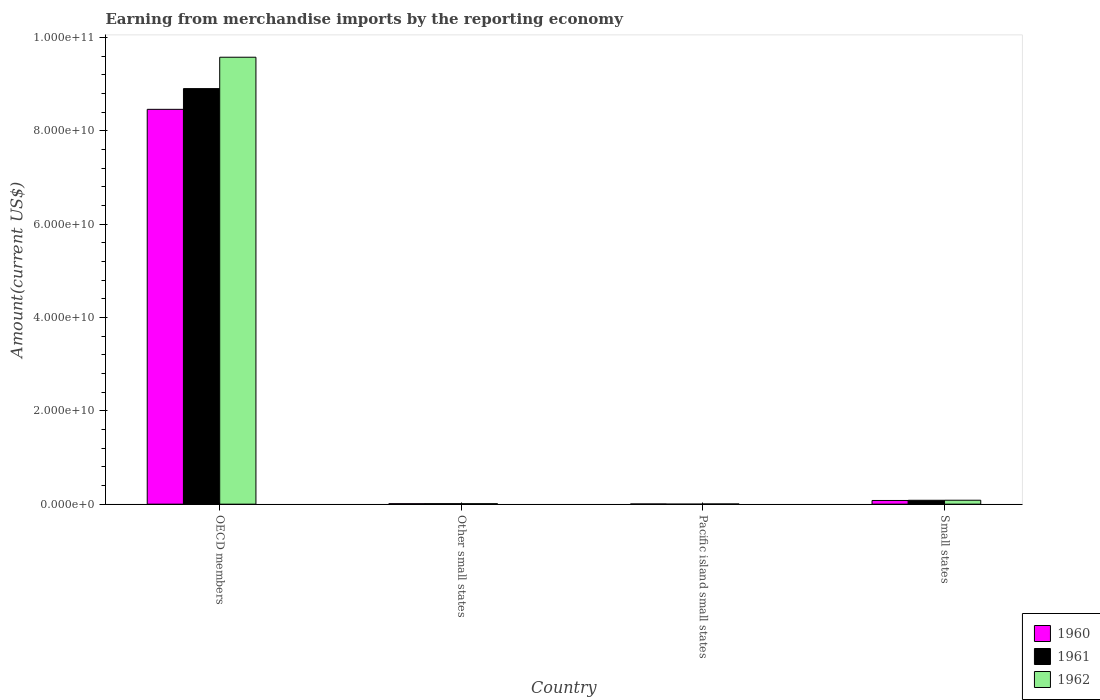How many bars are there on the 2nd tick from the left?
Your response must be concise. 3. How many bars are there on the 1st tick from the right?
Ensure brevity in your answer.  3. In how many cases, is the number of bars for a given country not equal to the number of legend labels?
Your answer should be compact. 0. What is the amount earned from merchandise imports in 1962 in OECD members?
Provide a succinct answer. 9.57e+1. Across all countries, what is the maximum amount earned from merchandise imports in 1962?
Provide a succinct answer. 9.57e+1. Across all countries, what is the minimum amount earned from merchandise imports in 1962?
Provide a succinct answer. 4.33e+07. In which country was the amount earned from merchandise imports in 1960 maximum?
Ensure brevity in your answer.  OECD members. In which country was the amount earned from merchandise imports in 1961 minimum?
Provide a short and direct response. Pacific island small states. What is the total amount earned from merchandise imports in 1960 in the graph?
Your answer should be very brief. 8.55e+1. What is the difference between the amount earned from merchandise imports in 1961 in OECD members and that in Other small states?
Make the answer very short. 8.89e+1. What is the difference between the amount earned from merchandise imports in 1962 in Other small states and the amount earned from merchandise imports in 1960 in OECD members?
Make the answer very short. -8.45e+1. What is the average amount earned from merchandise imports in 1960 per country?
Offer a very short reply. 2.14e+1. What is the difference between the amount earned from merchandise imports of/in 1961 and amount earned from merchandise imports of/in 1962 in Pacific island small states?
Give a very brief answer. -4.21e+07. In how many countries, is the amount earned from merchandise imports in 1960 greater than 52000000000 US$?
Provide a short and direct response. 1. What is the ratio of the amount earned from merchandise imports in 1960 in OECD members to that in Small states?
Ensure brevity in your answer.  107.01. Is the difference between the amount earned from merchandise imports in 1961 in OECD members and Other small states greater than the difference between the amount earned from merchandise imports in 1962 in OECD members and Other small states?
Your answer should be compact. No. What is the difference between the highest and the second highest amount earned from merchandise imports in 1960?
Ensure brevity in your answer.  8.38e+1. What is the difference between the highest and the lowest amount earned from merchandise imports in 1962?
Ensure brevity in your answer.  9.57e+1. Is the sum of the amount earned from merchandise imports in 1960 in Other small states and Pacific island small states greater than the maximum amount earned from merchandise imports in 1961 across all countries?
Your response must be concise. No. What does the 1st bar from the left in Small states represents?
Offer a very short reply. 1960. Are all the bars in the graph horizontal?
Your response must be concise. No. How many countries are there in the graph?
Keep it short and to the point. 4. Are the values on the major ticks of Y-axis written in scientific E-notation?
Your answer should be very brief. Yes. Does the graph contain any zero values?
Give a very brief answer. No. How many legend labels are there?
Keep it short and to the point. 3. How are the legend labels stacked?
Offer a terse response. Vertical. What is the title of the graph?
Offer a terse response. Earning from merchandise imports by the reporting economy. What is the label or title of the X-axis?
Offer a terse response. Country. What is the label or title of the Y-axis?
Offer a very short reply. Amount(current US$). What is the Amount(current US$) of 1960 in OECD members?
Ensure brevity in your answer.  8.46e+1. What is the Amount(current US$) in 1961 in OECD members?
Give a very brief answer. 8.90e+1. What is the Amount(current US$) of 1962 in OECD members?
Keep it short and to the point. 9.57e+1. What is the Amount(current US$) in 1960 in Other small states?
Make the answer very short. 1.00e+08. What is the Amount(current US$) in 1961 in Other small states?
Offer a very short reply. 1.02e+08. What is the Amount(current US$) in 1962 in Other small states?
Your answer should be compact. 1.04e+08. What is the Amount(current US$) in 1960 in Pacific island small states?
Keep it short and to the point. 4.12e+07. What is the Amount(current US$) of 1961 in Pacific island small states?
Make the answer very short. 1.20e+06. What is the Amount(current US$) in 1962 in Pacific island small states?
Offer a terse response. 4.33e+07. What is the Amount(current US$) of 1960 in Small states?
Give a very brief answer. 7.90e+08. What is the Amount(current US$) in 1961 in Small states?
Offer a terse response. 8.34e+08. What is the Amount(current US$) in 1962 in Small states?
Provide a succinct answer. 8.44e+08. Across all countries, what is the maximum Amount(current US$) of 1960?
Your answer should be compact. 8.46e+1. Across all countries, what is the maximum Amount(current US$) in 1961?
Ensure brevity in your answer.  8.90e+1. Across all countries, what is the maximum Amount(current US$) of 1962?
Give a very brief answer. 9.57e+1. Across all countries, what is the minimum Amount(current US$) in 1960?
Make the answer very short. 4.12e+07. Across all countries, what is the minimum Amount(current US$) in 1961?
Provide a succinct answer. 1.20e+06. Across all countries, what is the minimum Amount(current US$) of 1962?
Your answer should be compact. 4.33e+07. What is the total Amount(current US$) of 1960 in the graph?
Your answer should be very brief. 8.55e+1. What is the total Amount(current US$) in 1961 in the graph?
Offer a terse response. 9.00e+1. What is the total Amount(current US$) in 1962 in the graph?
Make the answer very short. 9.67e+1. What is the difference between the Amount(current US$) in 1960 in OECD members and that in Other small states?
Give a very brief answer. 8.45e+1. What is the difference between the Amount(current US$) in 1961 in OECD members and that in Other small states?
Give a very brief answer. 8.89e+1. What is the difference between the Amount(current US$) in 1962 in OECD members and that in Other small states?
Your answer should be very brief. 9.56e+1. What is the difference between the Amount(current US$) of 1960 in OECD members and that in Pacific island small states?
Make the answer very short. 8.45e+1. What is the difference between the Amount(current US$) of 1961 in OECD members and that in Pacific island small states?
Provide a succinct answer. 8.90e+1. What is the difference between the Amount(current US$) in 1962 in OECD members and that in Pacific island small states?
Offer a very short reply. 9.57e+1. What is the difference between the Amount(current US$) of 1960 in OECD members and that in Small states?
Provide a succinct answer. 8.38e+1. What is the difference between the Amount(current US$) in 1961 in OECD members and that in Small states?
Offer a very short reply. 8.82e+1. What is the difference between the Amount(current US$) in 1962 in OECD members and that in Small states?
Keep it short and to the point. 9.49e+1. What is the difference between the Amount(current US$) of 1960 in Other small states and that in Pacific island small states?
Your answer should be very brief. 5.90e+07. What is the difference between the Amount(current US$) in 1961 in Other small states and that in Pacific island small states?
Make the answer very short. 1.00e+08. What is the difference between the Amount(current US$) in 1962 in Other small states and that in Pacific island small states?
Your response must be concise. 6.08e+07. What is the difference between the Amount(current US$) of 1960 in Other small states and that in Small states?
Your answer should be compact. -6.90e+08. What is the difference between the Amount(current US$) of 1961 in Other small states and that in Small states?
Give a very brief answer. -7.32e+08. What is the difference between the Amount(current US$) in 1962 in Other small states and that in Small states?
Provide a short and direct response. -7.40e+08. What is the difference between the Amount(current US$) in 1960 in Pacific island small states and that in Small states?
Give a very brief answer. -7.49e+08. What is the difference between the Amount(current US$) in 1961 in Pacific island small states and that in Small states?
Offer a terse response. -8.32e+08. What is the difference between the Amount(current US$) in 1962 in Pacific island small states and that in Small states?
Offer a very short reply. -8.00e+08. What is the difference between the Amount(current US$) of 1960 in OECD members and the Amount(current US$) of 1961 in Other small states?
Your answer should be very brief. 8.45e+1. What is the difference between the Amount(current US$) of 1960 in OECD members and the Amount(current US$) of 1962 in Other small states?
Provide a succinct answer. 8.45e+1. What is the difference between the Amount(current US$) of 1961 in OECD members and the Amount(current US$) of 1962 in Other small states?
Offer a terse response. 8.89e+1. What is the difference between the Amount(current US$) of 1960 in OECD members and the Amount(current US$) of 1961 in Pacific island small states?
Provide a short and direct response. 8.46e+1. What is the difference between the Amount(current US$) in 1960 in OECD members and the Amount(current US$) in 1962 in Pacific island small states?
Provide a succinct answer. 8.45e+1. What is the difference between the Amount(current US$) in 1961 in OECD members and the Amount(current US$) in 1962 in Pacific island small states?
Your answer should be very brief. 8.90e+1. What is the difference between the Amount(current US$) in 1960 in OECD members and the Amount(current US$) in 1961 in Small states?
Give a very brief answer. 8.37e+1. What is the difference between the Amount(current US$) in 1960 in OECD members and the Amount(current US$) in 1962 in Small states?
Provide a short and direct response. 8.37e+1. What is the difference between the Amount(current US$) in 1961 in OECD members and the Amount(current US$) in 1962 in Small states?
Ensure brevity in your answer.  8.82e+1. What is the difference between the Amount(current US$) in 1960 in Other small states and the Amount(current US$) in 1961 in Pacific island small states?
Offer a very short reply. 9.90e+07. What is the difference between the Amount(current US$) in 1960 in Other small states and the Amount(current US$) in 1962 in Pacific island small states?
Your response must be concise. 5.69e+07. What is the difference between the Amount(current US$) in 1961 in Other small states and the Amount(current US$) in 1962 in Pacific island small states?
Offer a very short reply. 5.84e+07. What is the difference between the Amount(current US$) of 1960 in Other small states and the Amount(current US$) of 1961 in Small states?
Provide a succinct answer. -7.34e+08. What is the difference between the Amount(current US$) of 1960 in Other small states and the Amount(current US$) of 1962 in Small states?
Offer a terse response. -7.44e+08. What is the difference between the Amount(current US$) of 1961 in Other small states and the Amount(current US$) of 1962 in Small states?
Give a very brief answer. -7.42e+08. What is the difference between the Amount(current US$) of 1960 in Pacific island small states and the Amount(current US$) of 1961 in Small states?
Provide a succinct answer. -7.92e+08. What is the difference between the Amount(current US$) in 1960 in Pacific island small states and the Amount(current US$) in 1962 in Small states?
Offer a very short reply. -8.02e+08. What is the difference between the Amount(current US$) in 1961 in Pacific island small states and the Amount(current US$) in 1962 in Small states?
Keep it short and to the point. -8.42e+08. What is the average Amount(current US$) of 1960 per country?
Your response must be concise. 2.14e+1. What is the average Amount(current US$) of 1961 per country?
Make the answer very short. 2.25e+1. What is the average Amount(current US$) of 1962 per country?
Ensure brevity in your answer.  2.42e+1. What is the difference between the Amount(current US$) of 1960 and Amount(current US$) of 1961 in OECD members?
Provide a succinct answer. -4.44e+09. What is the difference between the Amount(current US$) of 1960 and Amount(current US$) of 1962 in OECD members?
Provide a succinct answer. -1.12e+1. What is the difference between the Amount(current US$) in 1961 and Amount(current US$) in 1962 in OECD members?
Provide a succinct answer. -6.73e+09. What is the difference between the Amount(current US$) in 1960 and Amount(current US$) in 1961 in Other small states?
Your response must be concise. -1.50e+06. What is the difference between the Amount(current US$) in 1960 and Amount(current US$) in 1962 in Other small states?
Your response must be concise. -3.90e+06. What is the difference between the Amount(current US$) of 1961 and Amount(current US$) of 1962 in Other small states?
Ensure brevity in your answer.  -2.40e+06. What is the difference between the Amount(current US$) in 1960 and Amount(current US$) in 1961 in Pacific island small states?
Your answer should be compact. 4.00e+07. What is the difference between the Amount(current US$) in 1960 and Amount(current US$) in 1962 in Pacific island small states?
Give a very brief answer. -2.10e+06. What is the difference between the Amount(current US$) of 1961 and Amount(current US$) of 1962 in Pacific island small states?
Your response must be concise. -4.21e+07. What is the difference between the Amount(current US$) of 1960 and Amount(current US$) of 1961 in Small states?
Offer a very short reply. -4.33e+07. What is the difference between the Amount(current US$) in 1960 and Amount(current US$) in 1962 in Small states?
Your answer should be very brief. -5.33e+07. What is the difference between the Amount(current US$) in 1961 and Amount(current US$) in 1962 in Small states?
Provide a succinct answer. -1.00e+07. What is the ratio of the Amount(current US$) in 1960 in OECD members to that in Other small states?
Provide a succinct answer. 844.13. What is the ratio of the Amount(current US$) of 1961 in OECD members to that in Other small states?
Give a very brief answer. 875.34. What is the ratio of the Amount(current US$) of 1962 in OECD members to that in Other small states?
Make the answer very short. 919.76. What is the ratio of the Amount(current US$) of 1960 in OECD members to that in Pacific island small states?
Offer a very short reply. 2052.96. What is the ratio of the Amount(current US$) in 1961 in OECD members to that in Pacific island small states?
Your answer should be compact. 7.42e+04. What is the ratio of the Amount(current US$) in 1962 in OECD members to that in Pacific island small states?
Ensure brevity in your answer.  2211.24. What is the ratio of the Amount(current US$) of 1960 in OECD members to that in Small states?
Make the answer very short. 107.01. What is the ratio of the Amount(current US$) of 1961 in OECD members to that in Small states?
Your answer should be very brief. 106.78. What is the ratio of the Amount(current US$) in 1962 in OECD members to that in Small states?
Provide a succinct answer. 113.48. What is the ratio of the Amount(current US$) in 1960 in Other small states to that in Pacific island small states?
Make the answer very short. 2.43. What is the ratio of the Amount(current US$) of 1961 in Other small states to that in Pacific island small states?
Provide a succinct answer. 84.75. What is the ratio of the Amount(current US$) of 1962 in Other small states to that in Pacific island small states?
Give a very brief answer. 2.4. What is the ratio of the Amount(current US$) in 1960 in Other small states to that in Small states?
Make the answer very short. 0.13. What is the ratio of the Amount(current US$) of 1961 in Other small states to that in Small states?
Provide a succinct answer. 0.12. What is the ratio of the Amount(current US$) in 1962 in Other small states to that in Small states?
Your answer should be compact. 0.12. What is the ratio of the Amount(current US$) in 1960 in Pacific island small states to that in Small states?
Provide a short and direct response. 0.05. What is the ratio of the Amount(current US$) in 1961 in Pacific island small states to that in Small states?
Offer a very short reply. 0. What is the ratio of the Amount(current US$) of 1962 in Pacific island small states to that in Small states?
Give a very brief answer. 0.05. What is the difference between the highest and the second highest Amount(current US$) in 1960?
Give a very brief answer. 8.38e+1. What is the difference between the highest and the second highest Amount(current US$) in 1961?
Offer a terse response. 8.82e+1. What is the difference between the highest and the second highest Amount(current US$) in 1962?
Make the answer very short. 9.49e+1. What is the difference between the highest and the lowest Amount(current US$) in 1960?
Provide a succinct answer. 8.45e+1. What is the difference between the highest and the lowest Amount(current US$) of 1961?
Your answer should be compact. 8.90e+1. What is the difference between the highest and the lowest Amount(current US$) in 1962?
Offer a terse response. 9.57e+1. 